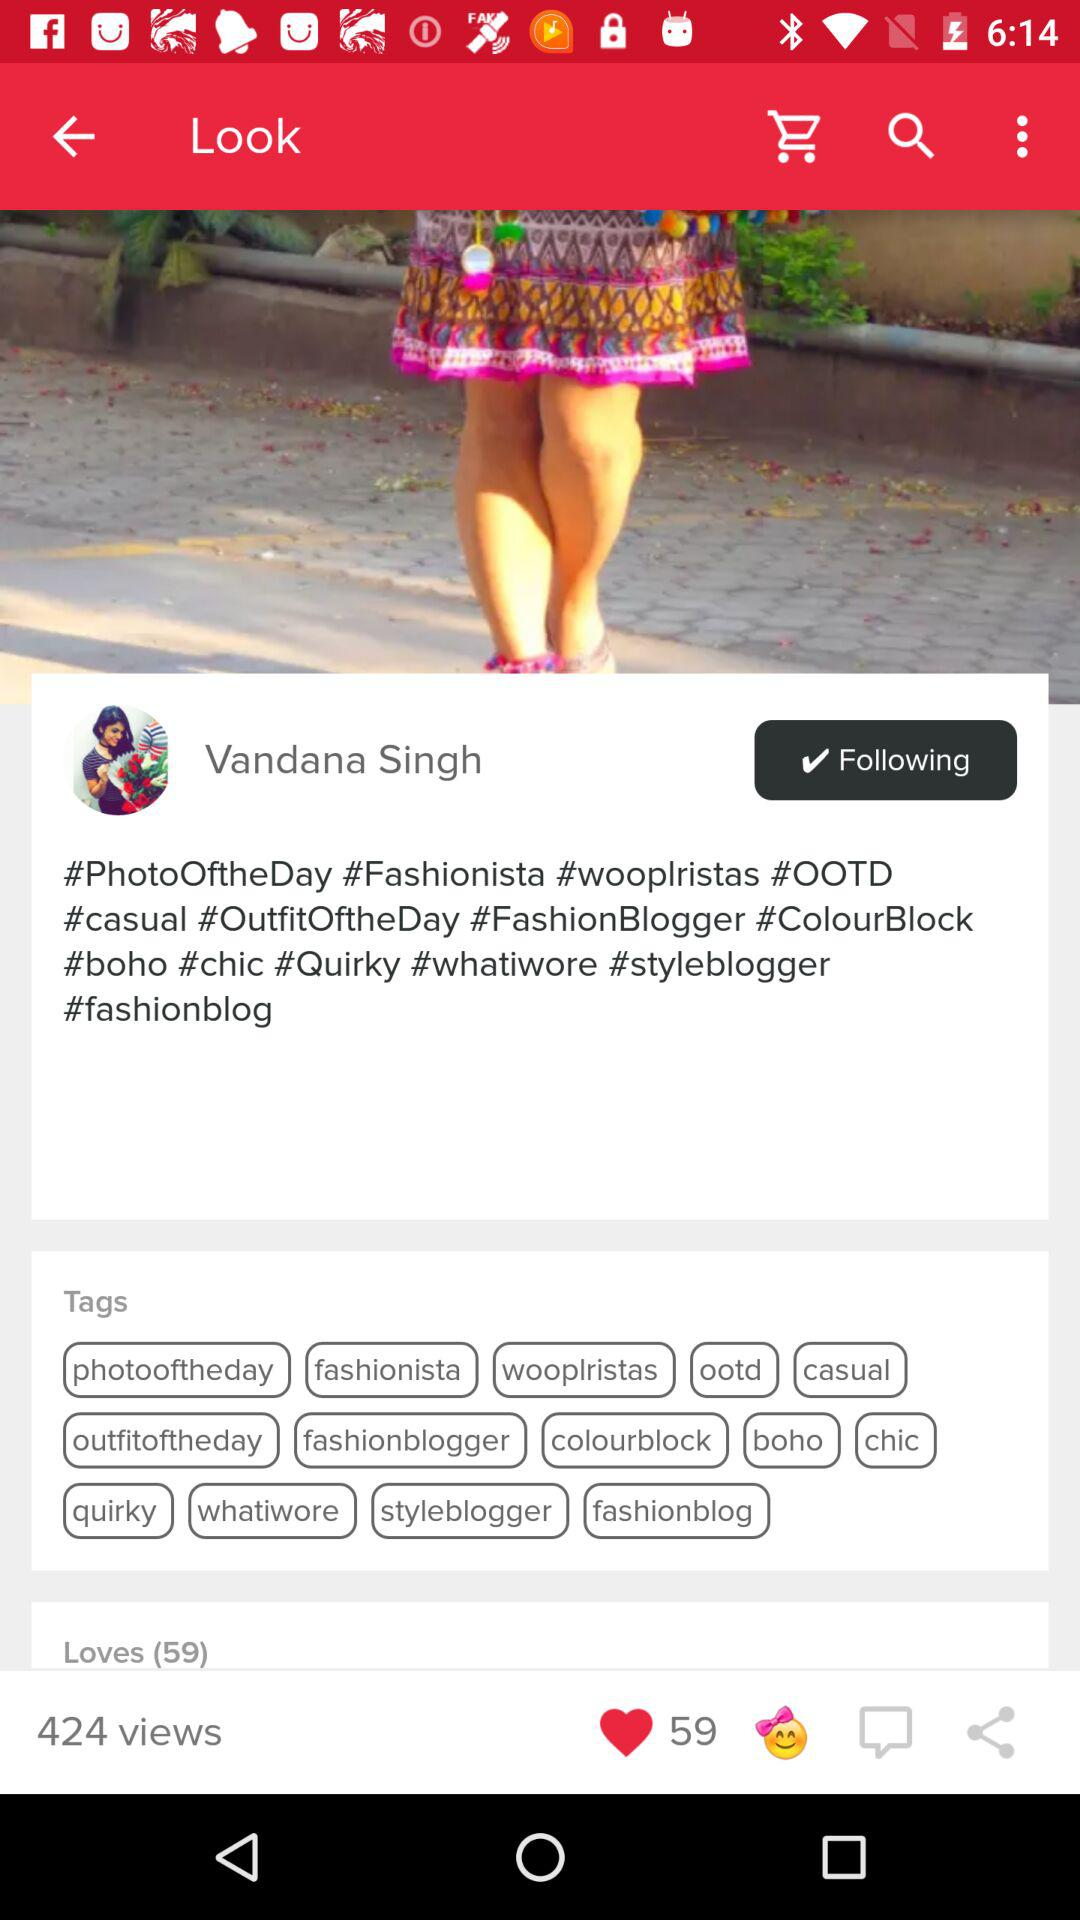How many views are there? There are 424 views. 